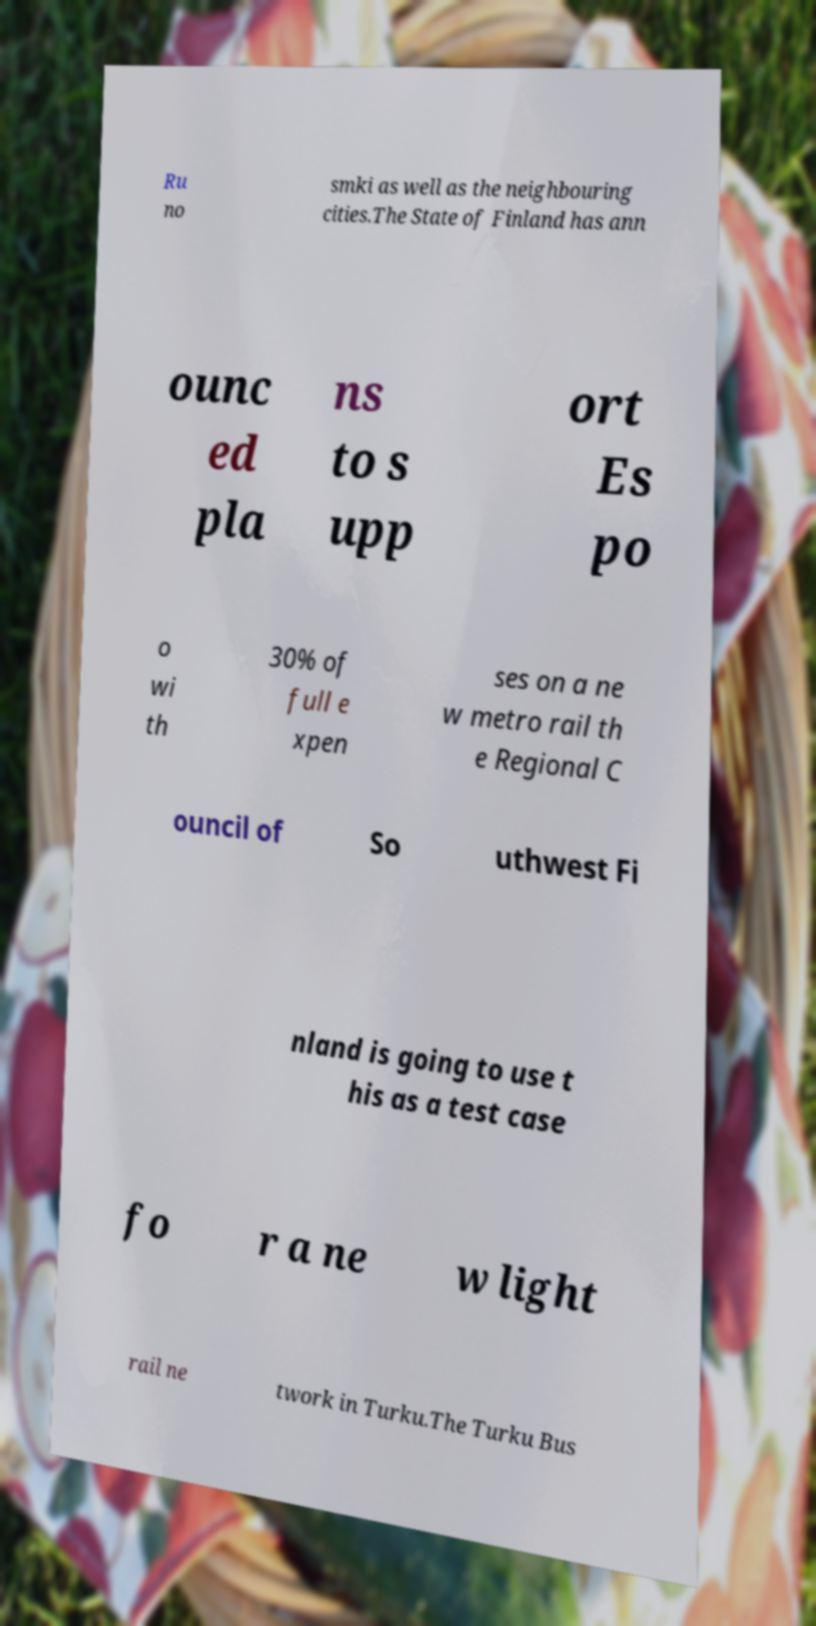For documentation purposes, I need the text within this image transcribed. Could you provide that? Ru no smki as well as the neighbouring cities.The State of Finland has ann ounc ed pla ns to s upp ort Es po o wi th 30% of full e xpen ses on a ne w metro rail th e Regional C ouncil of So uthwest Fi nland is going to use t his as a test case fo r a ne w light rail ne twork in Turku.The Turku Bus 